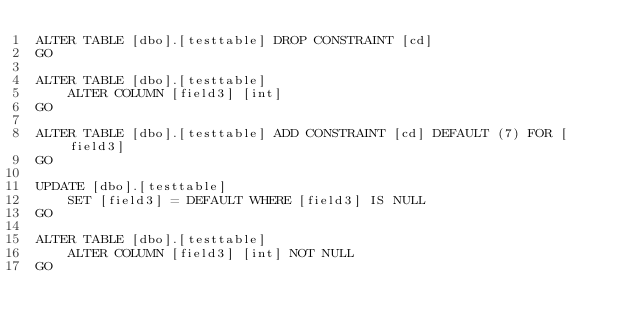Convert code to text. <code><loc_0><loc_0><loc_500><loc_500><_SQL_>ALTER TABLE [dbo].[testtable] DROP CONSTRAINT [cd]
GO

ALTER TABLE [dbo].[testtable]
	ALTER COLUMN [field3] [int]
GO

ALTER TABLE [dbo].[testtable] ADD CONSTRAINT [cd] DEFAULT (7) FOR [field3]
GO

UPDATE [dbo].[testtable]
	SET [field3] = DEFAULT WHERE [field3] IS NULL
GO

ALTER TABLE [dbo].[testtable]
	ALTER COLUMN [field3] [int] NOT NULL
GO
</code> 